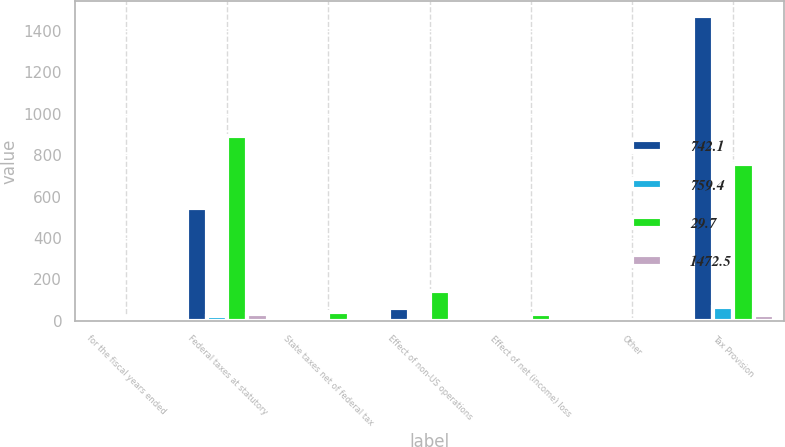Convert chart. <chart><loc_0><loc_0><loc_500><loc_500><stacked_bar_chart><ecel><fcel>for the fiscal years ended<fcel>Federal taxes at statutory<fcel>State taxes net of federal tax<fcel>Effect of non-US operations<fcel>Effect of net (income) loss<fcel>Other<fcel>Tax Provision<nl><fcel>742.1<fcel>20.55<fcel>542.7<fcel>16.6<fcel>61.9<fcel>5.3<fcel>1<fcel>1472.5<nl><fcel>759.4<fcel>20.55<fcel>24.5<fcel>0.7<fcel>2.8<fcel>0.2<fcel>0.1<fcel>66.5<nl><fcel>29.7<fcel>20.55<fcel>892.2<fcel>41.4<fcel>146.2<fcel>32.6<fcel>4.6<fcel>759.4<nl><fcel>1472.5<fcel>20.55<fcel>35<fcel>1.6<fcel>5.7<fcel>1.3<fcel>0.2<fcel>29.8<nl></chart> 